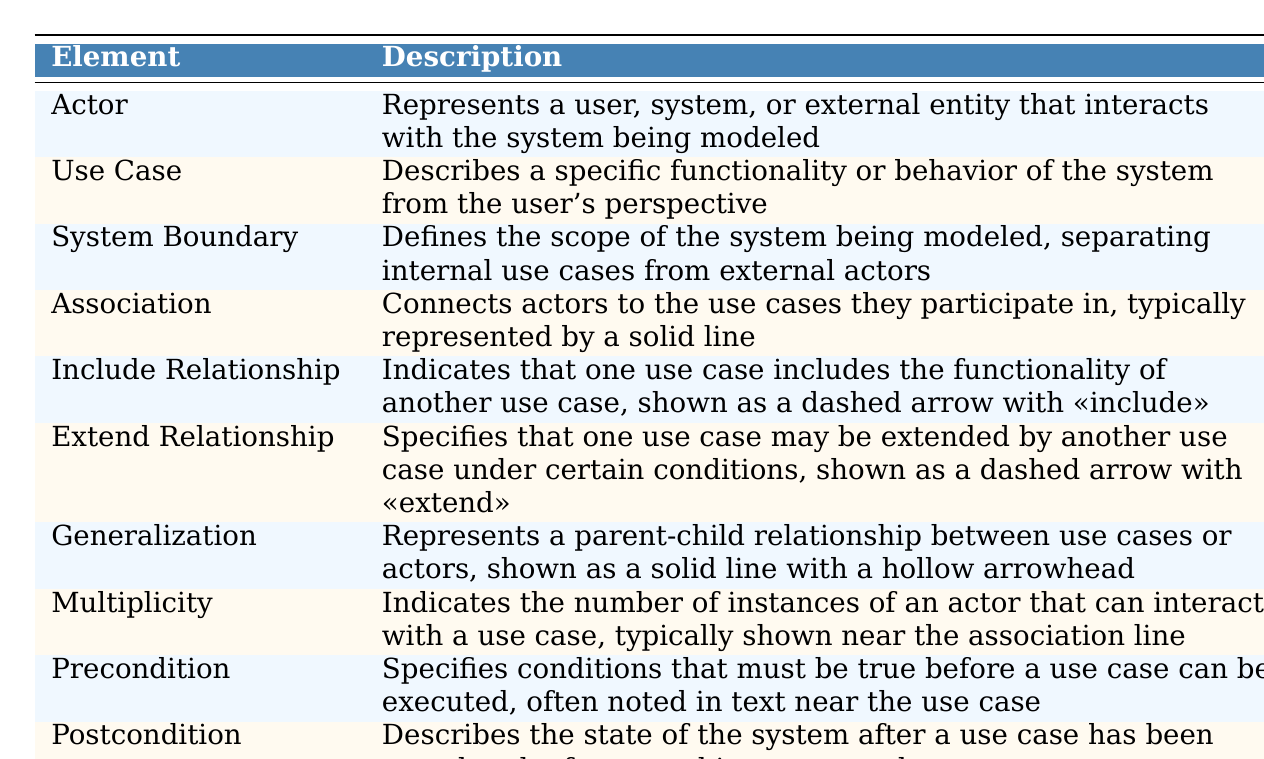What is an Actor in the context of use case diagrams? An Actor represents a user, system, or external entity that interacts with the system being modeled, as stated in the description in the table.
Answer: An Actor is a user or entity interacting with the system What does a Use Case describe? A Use Case describes specific functionality or behavior of the system from the user's perspective, as indicated in the table.
Answer: A Use Case describes system functionality from the user's perspective What is the purpose of a System Boundary? The purpose of a System Boundary is to define the scope of the system being modeled, separating internal use cases from external actors, as detailed in the table.
Answer: A System Boundary defines the scope of the system What connects actors to the use cases in a use case diagram? Associations connect actors to the use cases they participate in, which is mentioned in the table.
Answer: Associations connect actors to use cases Is the Include Relationship depicted as a solid line? No, the Include Relationship is shown as a dashed arrow with <<include>>, which is stated in the description.
Answer: No, it's shown as a dashed arrow How many types of relationships are mentioned in the table? The table mentions three types of relationships: Include Relationship, Extend Relationship, and Generalization. This is derived from the individual descriptions.
Answer: Three types of relationships Which elements specify essential conditions before and after executing a use case? Precondition specifies conditions before a use case is executed, while Postcondition describes the state after it has been completed, according to the table.
Answer: Precondition and Postcondition If a use case can be extended by another use case, what relationship does it represent? It represents an Extend Relationship, which is denoted as a dashed arrow with <<extend>> in the table.
Answer: It represents an Extend Relationship Which two elements indicate the number of instances of an actor that interacts with a use case? The table indicates that Multiplicity shows the number of instances, while Association connects them, suggesting their interaction.
Answer: Multiplicity and Association What is the relationship type that shows a parent-child connection? The Generalization relationship represents a parent-child connection between use cases or actors, as depicted in the table.
Answer: The Generalization relationship Can you name at least two elements that can potentially involve multiple entities interacting with a use case? Yes, the elements Actor and Multiplicity involve multiple entities, as described in their respective definitions in the table.
Answer: Actor and Multiplicity 